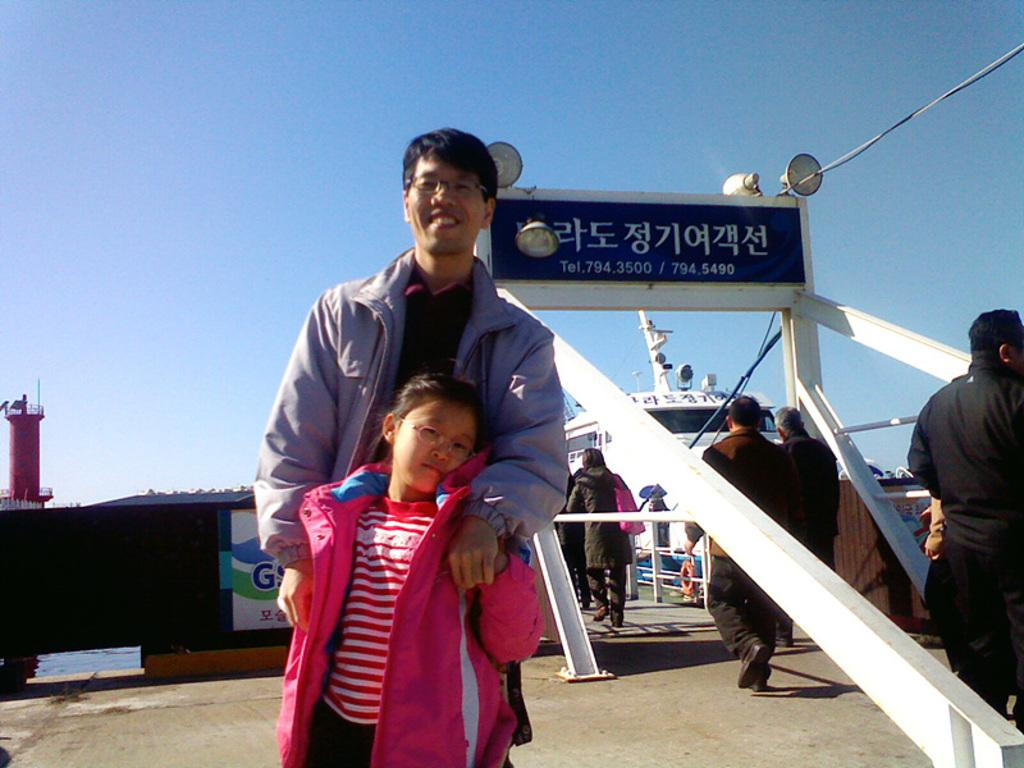How many people are present in the image? There are many people in the image. What is at the bottom of the image? There is ground at the bottom of the image. What can be seen in the background of the image? There is a name board in the background of the image. What is the girl in the front of the image wearing? A girl is wearing a pink jacket in the front of the image. Can you see a nest in the image? There is no nest present in the image. 